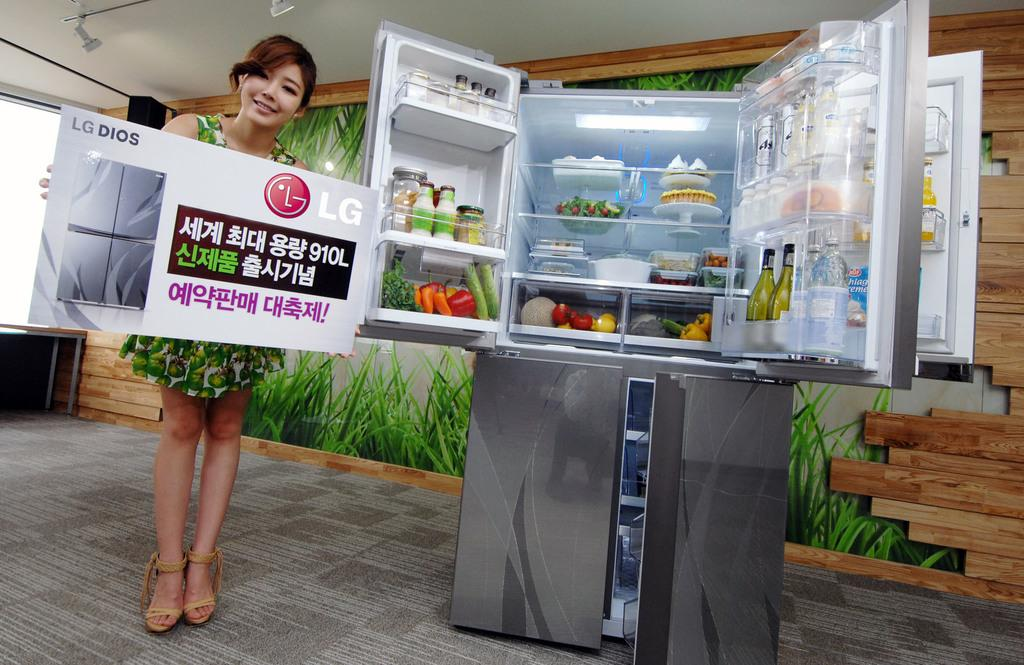<image>
Offer a succinct explanation of the picture presented. A woman standing next to a LG Dios refrigerator holding a sign for the same product. 